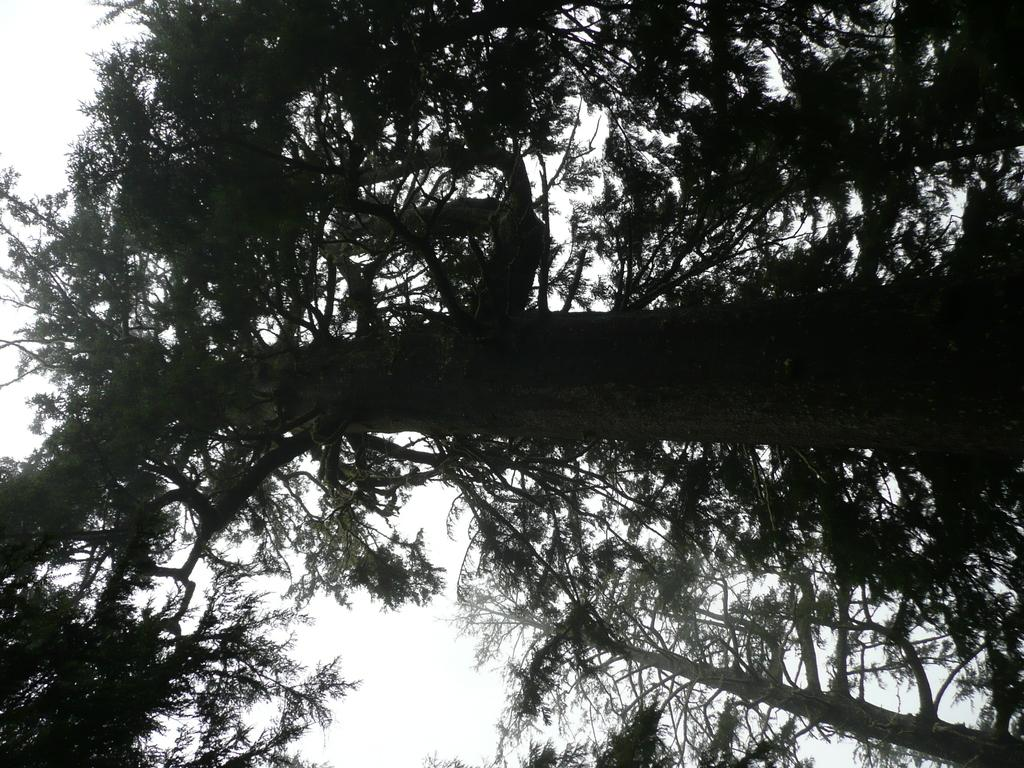What type of plant can be seen in the image? There is a tree in the image. What part of the natural environment is visible in the image? The sky is visible in the image. What type of straw is the goose using to feed the kitten in the image? There is no goose or kitten present in the image, and therefore no straw or feeding activity can be observed. 